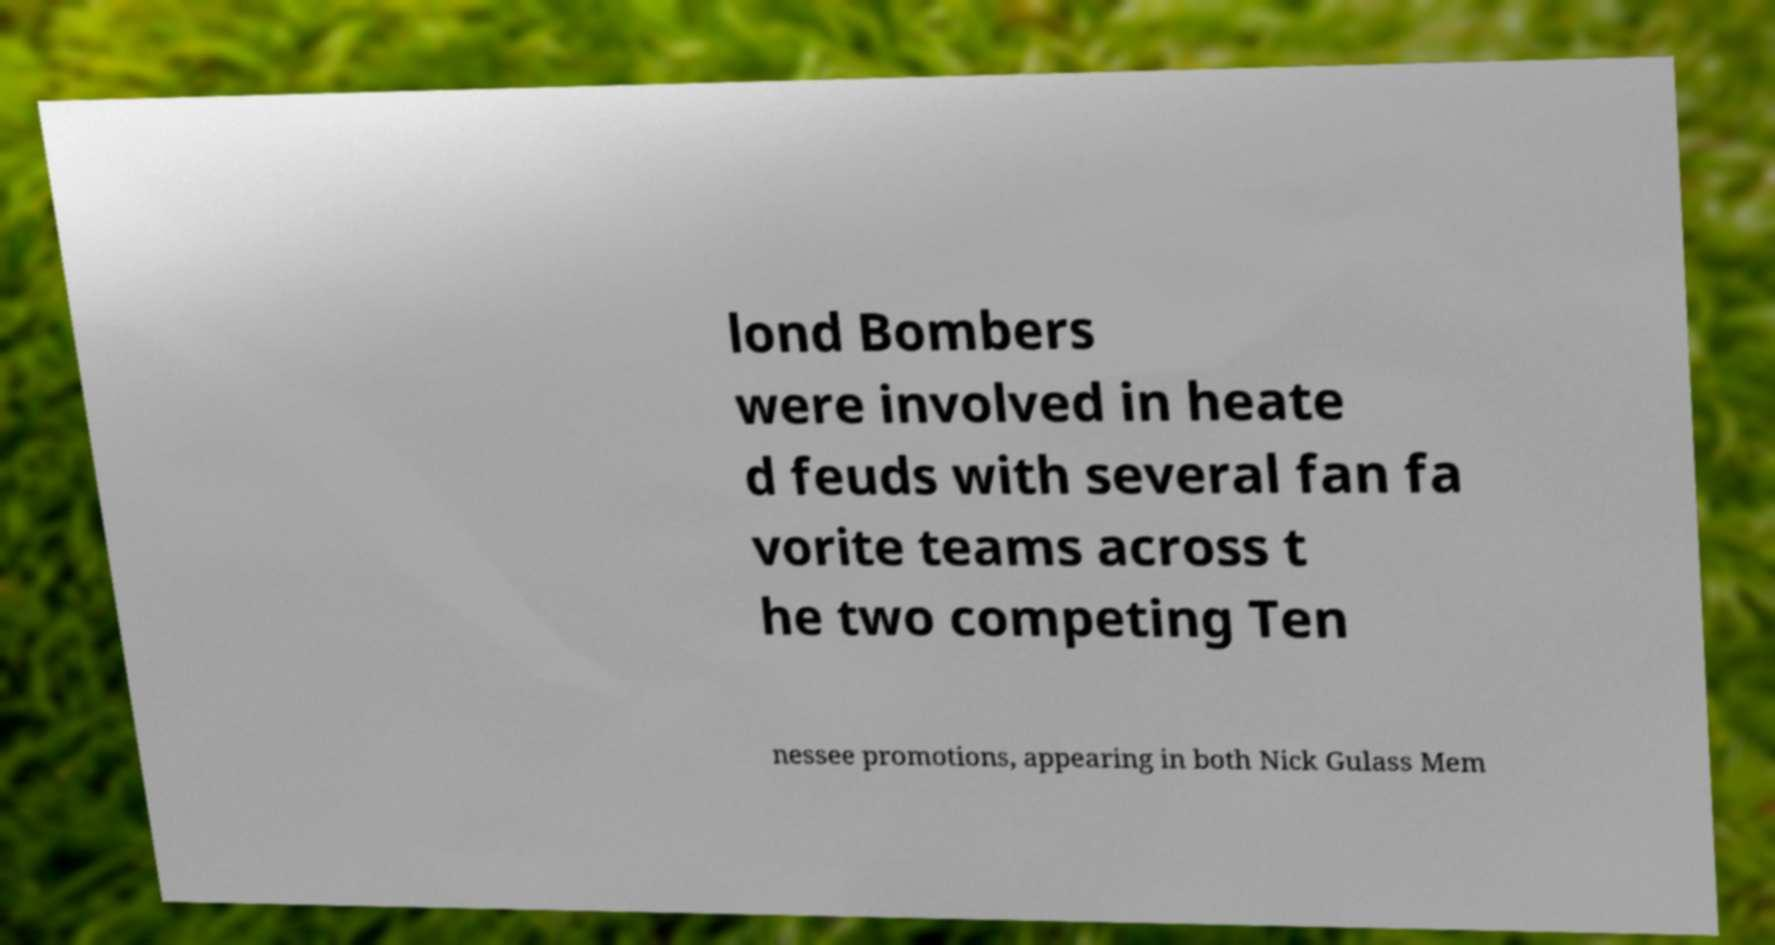I need the written content from this picture converted into text. Can you do that? lond Bombers were involved in heate d feuds with several fan fa vorite teams across t he two competing Ten nessee promotions, appearing in both Nick Gulass Mem 